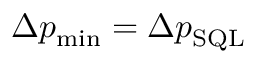Convert formula to latex. <formula><loc_0><loc_0><loc_500><loc_500>\Delta p _ { \min } = \Delta p _ { S Q L }</formula> 